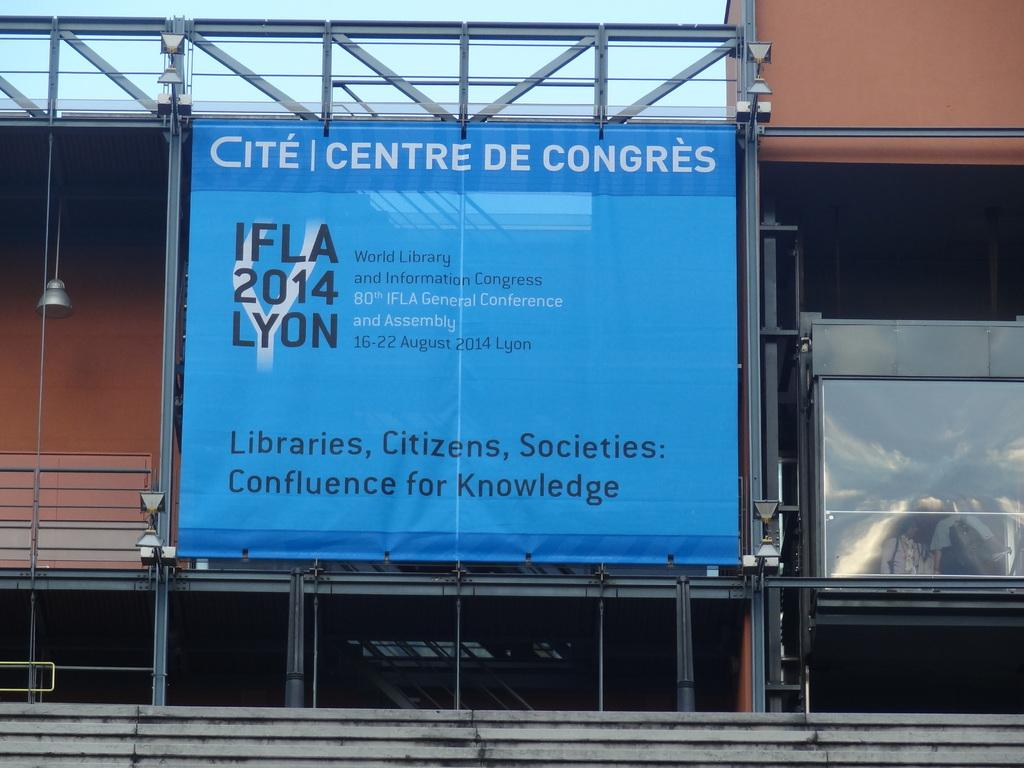Provide a one-sentence caption for the provided image. Centre De Congres IFLA 2014 Lyon poster for knowledge. 